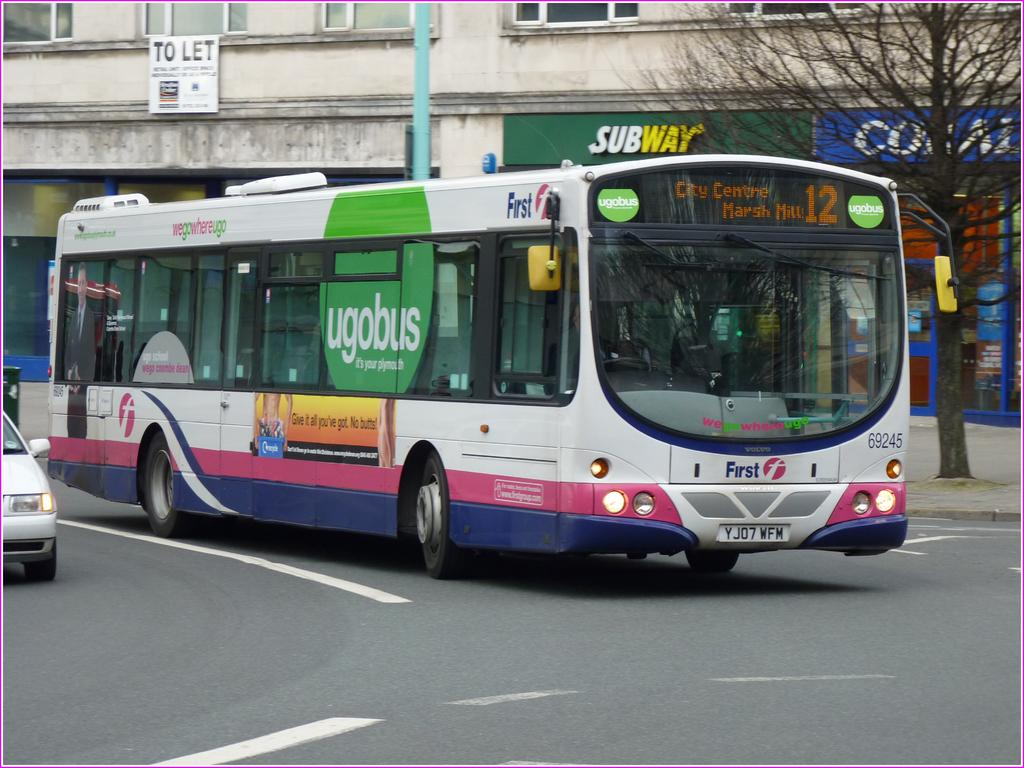<image>
Offer a succinct explanation of the picture presented. Plymoth's bus number 12 is heading into the roundabout. 